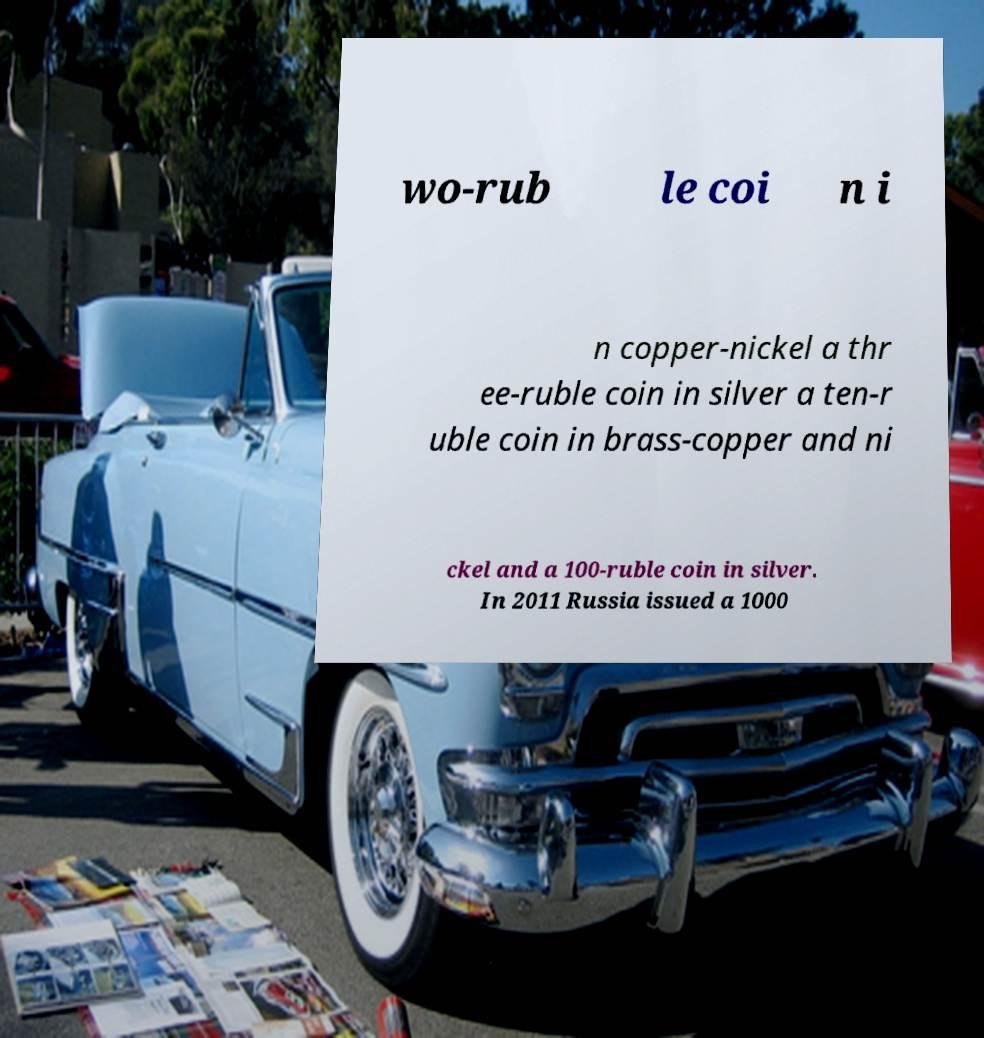Can you read and provide the text displayed in the image?This photo seems to have some interesting text. Can you extract and type it out for me? wo-rub le coi n i n copper-nickel a thr ee-ruble coin in silver a ten-r uble coin in brass-copper and ni ckel and a 100-ruble coin in silver. In 2011 Russia issued a 1000 